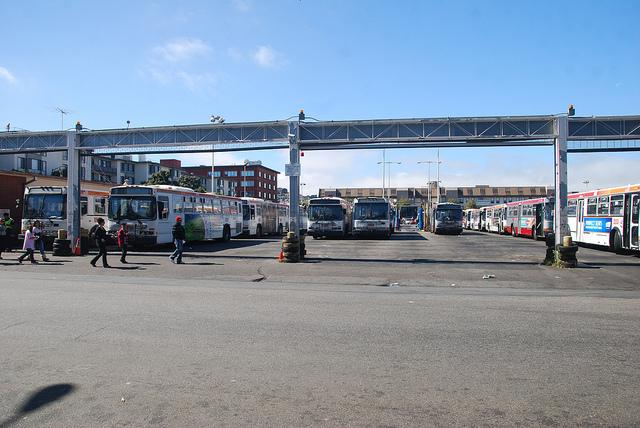How many rows of buses are visible?

Choices:
A) six
B) four
C) three
D) five six 